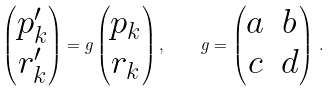<formula> <loc_0><loc_0><loc_500><loc_500>\begin{pmatrix} p _ { k } ^ { \prime } \\ r _ { k } ^ { \prime } \end{pmatrix} = g \begin{pmatrix} p _ { k } \\ r _ { k } \end{pmatrix} , \quad g = \begin{pmatrix} a & b \\ c & d \end{pmatrix} \, .</formula> 